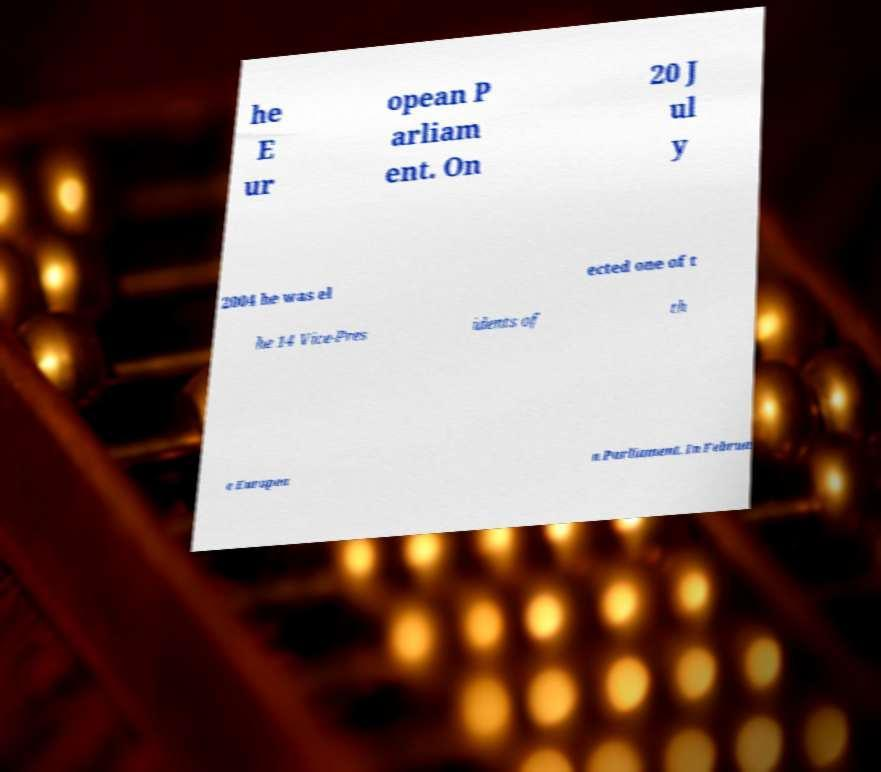Can you accurately transcribe the text from the provided image for me? he E ur opean P arliam ent. On 20 J ul y 2004 he was el ected one of t he 14 Vice-Pres idents of th e Europea n Parliament. In Februa 